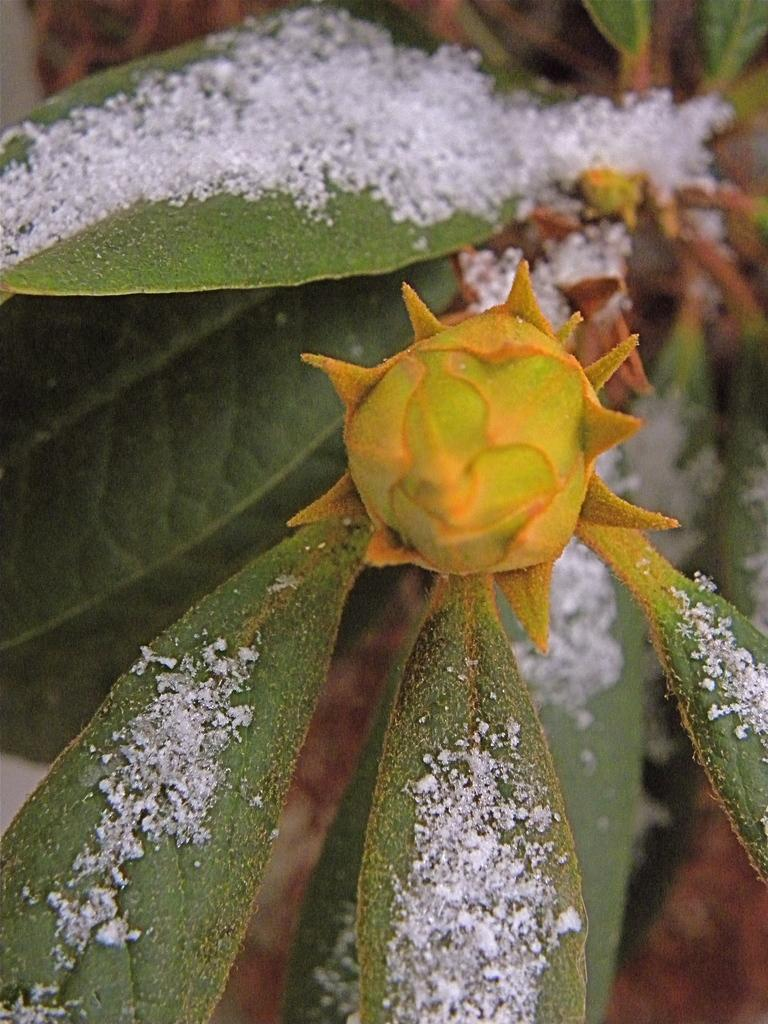What is present in the image? There is a plant in the image. What can be observed on the plant? The plant has buds on it. How does the plant help the dock in the image? There is no dock present in the image, and the plant is not interacting with any dock. 